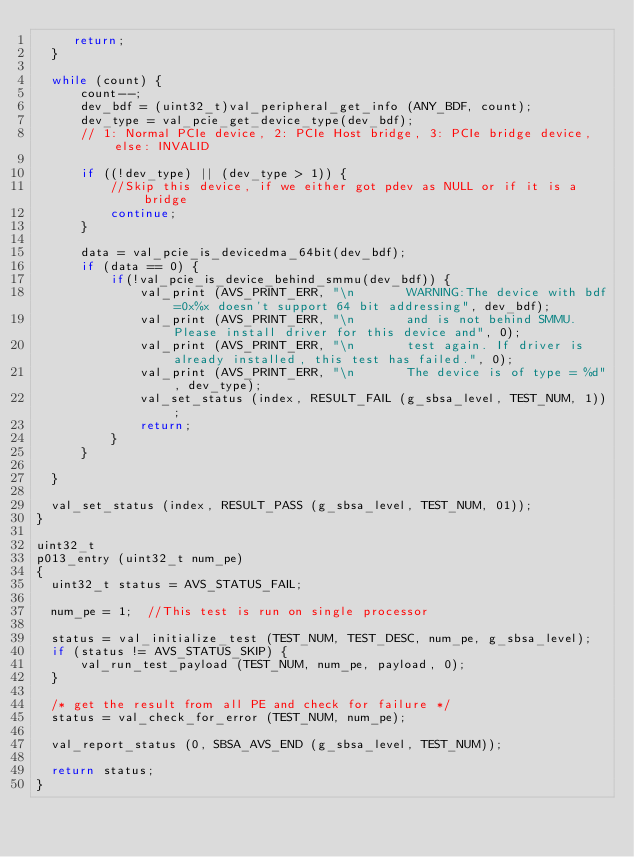<code> <loc_0><loc_0><loc_500><loc_500><_C_>     return;
  }

  while (count) {
      count--;
      dev_bdf = (uint32_t)val_peripheral_get_info (ANY_BDF, count);
      dev_type = val_pcie_get_device_type(dev_bdf);
      // 1: Normal PCIe device, 2: PCIe Host bridge, 3: PCIe bridge device, else: INVALID

      if ((!dev_type) || (dev_type > 1)) {
          //Skip this device, if we either got pdev as NULL or if it is a bridge
          continue;
      }

      data = val_pcie_is_devicedma_64bit(dev_bdf);
      if (data == 0) {
          if(!val_pcie_is_device_behind_smmu(dev_bdf)) {
              val_print (AVS_PRINT_ERR, "\n       WARNING:The device with bdf=0x%x doesn't support 64 bit addressing", dev_bdf);
              val_print (AVS_PRINT_ERR, "\n       and is not behind SMMU. Please install driver for this device and", 0);
              val_print (AVS_PRINT_ERR, "\n       test again. If driver is already installed, this test has failed.", 0);
              val_print (AVS_PRINT_ERR, "\n       The device is of type = %d", dev_type);
              val_set_status (index, RESULT_FAIL (g_sbsa_level, TEST_NUM, 1));
              return;
          }
      }

  }

  val_set_status (index, RESULT_PASS (g_sbsa_level, TEST_NUM, 01));
}

uint32_t
p013_entry (uint32_t num_pe)
{
  uint32_t status = AVS_STATUS_FAIL;

  num_pe = 1;  //This test is run on single processor

  status = val_initialize_test (TEST_NUM, TEST_DESC, num_pe, g_sbsa_level);
  if (status != AVS_STATUS_SKIP) {
      val_run_test_payload (TEST_NUM, num_pe, payload, 0);
  }

  /* get the result from all PE and check for failure */
  status = val_check_for_error (TEST_NUM, num_pe);

  val_report_status (0, SBSA_AVS_END (g_sbsa_level, TEST_NUM));

  return status;
}
</code> 